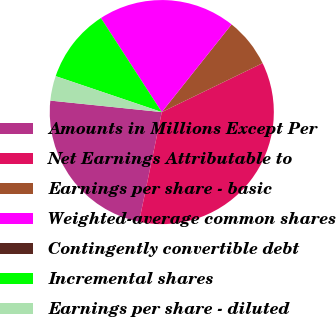Convert chart to OTSL. <chart><loc_0><loc_0><loc_500><loc_500><pie_chart><fcel>Amounts in Millions Except Per<fcel>Net Earnings Attributable to<fcel>Earnings per share - basic<fcel>Weighted-average common shares<fcel>Contingently convertible debt<fcel>Incremental shares<fcel>Earnings per share - diluted<nl><fcel>23.38%<fcel>35.44%<fcel>7.11%<fcel>19.83%<fcel>0.01%<fcel>10.66%<fcel>3.56%<nl></chart> 